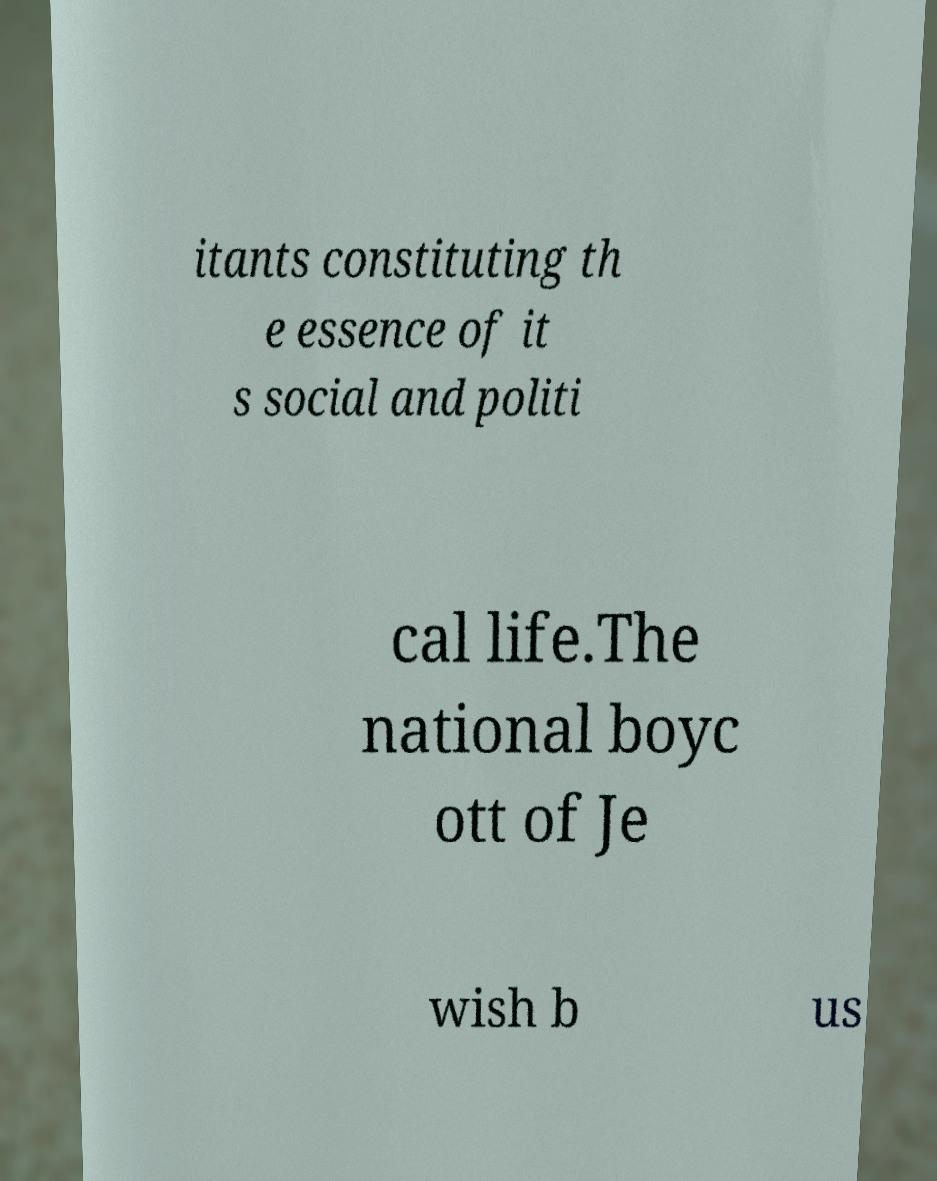Could you assist in decoding the text presented in this image and type it out clearly? itants constituting th e essence of it s social and politi cal life.The national boyc ott of Je wish b us 